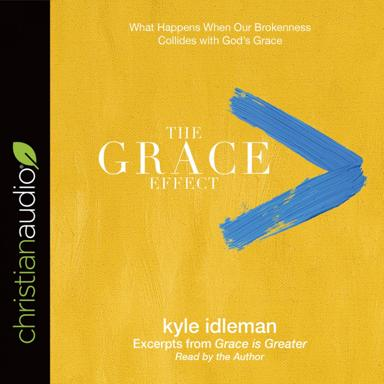What sort of audience do you think would be drawn to this audiobook? This audiobook is likely to appeal to a Christian audience seeking deeper insight into their faith and the concept of grace. Individuals facing personal challenges or seeking spiritual growth may find comfort and guidance in the narratives and teachings of Kyle Idleman. Furthermore, the accessible format makes it a good fit for busy people who prefer to listen to enriching content during their commutes or daily activities. 